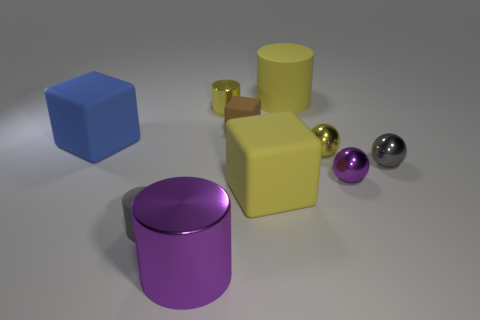Subtract 1 cylinders. How many cylinders are left? 3 Subtract all cubes. How many objects are left? 7 Subtract 1 gray cylinders. How many objects are left? 9 Subtract all small cylinders. Subtract all large gray cylinders. How many objects are left? 8 Add 1 tiny gray balls. How many tiny gray balls are left? 2 Add 8 large cyan matte balls. How many large cyan matte balls exist? 8 